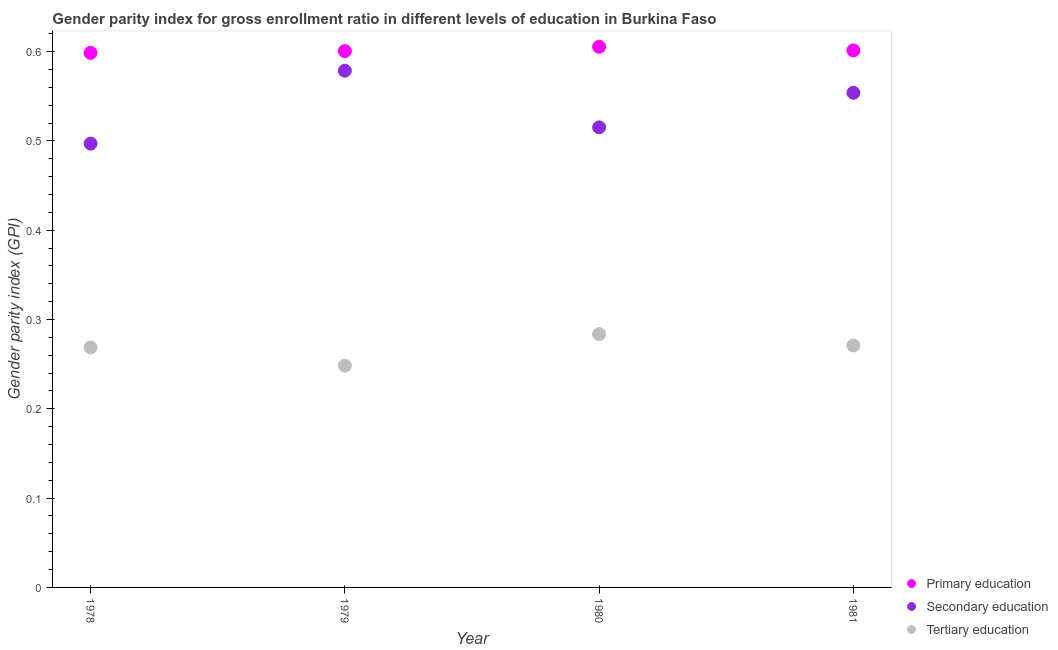Is the number of dotlines equal to the number of legend labels?
Provide a succinct answer. Yes. What is the gender parity index in secondary education in 1978?
Your answer should be compact. 0.5. Across all years, what is the maximum gender parity index in tertiary education?
Your response must be concise. 0.28. Across all years, what is the minimum gender parity index in secondary education?
Ensure brevity in your answer.  0.5. In which year was the gender parity index in primary education minimum?
Keep it short and to the point. 1978. What is the total gender parity index in secondary education in the graph?
Provide a succinct answer. 2.14. What is the difference between the gender parity index in primary education in 1978 and that in 1979?
Your answer should be compact. -0. What is the difference between the gender parity index in secondary education in 1979 and the gender parity index in primary education in 1978?
Your response must be concise. -0.02. What is the average gender parity index in secondary education per year?
Your response must be concise. 0.54. In the year 1978, what is the difference between the gender parity index in tertiary education and gender parity index in secondary education?
Provide a short and direct response. -0.23. What is the ratio of the gender parity index in primary education in 1980 to that in 1981?
Keep it short and to the point. 1.01. Is the gender parity index in tertiary education in 1978 less than that in 1981?
Offer a terse response. Yes. Is the difference between the gender parity index in tertiary education in 1978 and 1980 greater than the difference between the gender parity index in secondary education in 1978 and 1980?
Ensure brevity in your answer.  Yes. What is the difference between the highest and the second highest gender parity index in primary education?
Make the answer very short. 0. What is the difference between the highest and the lowest gender parity index in secondary education?
Give a very brief answer. 0.08. Is it the case that in every year, the sum of the gender parity index in primary education and gender parity index in secondary education is greater than the gender parity index in tertiary education?
Provide a short and direct response. Yes. Is the gender parity index in tertiary education strictly greater than the gender parity index in primary education over the years?
Give a very brief answer. No. How many dotlines are there?
Your response must be concise. 3. How many legend labels are there?
Your answer should be very brief. 3. How are the legend labels stacked?
Provide a succinct answer. Vertical. What is the title of the graph?
Offer a very short reply. Gender parity index for gross enrollment ratio in different levels of education in Burkina Faso. What is the label or title of the Y-axis?
Offer a terse response. Gender parity index (GPI). What is the Gender parity index (GPI) in Primary education in 1978?
Provide a succinct answer. 0.6. What is the Gender parity index (GPI) of Secondary education in 1978?
Offer a terse response. 0.5. What is the Gender parity index (GPI) of Tertiary education in 1978?
Ensure brevity in your answer.  0.27. What is the Gender parity index (GPI) of Primary education in 1979?
Ensure brevity in your answer.  0.6. What is the Gender parity index (GPI) of Secondary education in 1979?
Provide a succinct answer. 0.58. What is the Gender parity index (GPI) in Tertiary education in 1979?
Provide a succinct answer. 0.25. What is the Gender parity index (GPI) of Primary education in 1980?
Your response must be concise. 0.61. What is the Gender parity index (GPI) in Secondary education in 1980?
Give a very brief answer. 0.52. What is the Gender parity index (GPI) of Tertiary education in 1980?
Provide a succinct answer. 0.28. What is the Gender parity index (GPI) of Primary education in 1981?
Your response must be concise. 0.6. What is the Gender parity index (GPI) in Secondary education in 1981?
Your answer should be compact. 0.55. What is the Gender parity index (GPI) in Tertiary education in 1981?
Your answer should be very brief. 0.27. Across all years, what is the maximum Gender parity index (GPI) in Primary education?
Ensure brevity in your answer.  0.61. Across all years, what is the maximum Gender parity index (GPI) in Secondary education?
Ensure brevity in your answer.  0.58. Across all years, what is the maximum Gender parity index (GPI) of Tertiary education?
Offer a very short reply. 0.28. Across all years, what is the minimum Gender parity index (GPI) of Primary education?
Your response must be concise. 0.6. Across all years, what is the minimum Gender parity index (GPI) in Secondary education?
Your response must be concise. 0.5. Across all years, what is the minimum Gender parity index (GPI) of Tertiary education?
Provide a short and direct response. 0.25. What is the total Gender parity index (GPI) of Primary education in the graph?
Your answer should be very brief. 2.41. What is the total Gender parity index (GPI) in Secondary education in the graph?
Keep it short and to the point. 2.14. What is the total Gender parity index (GPI) of Tertiary education in the graph?
Offer a terse response. 1.07. What is the difference between the Gender parity index (GPI) in Primary education in 1978 and that in 1979?
Ensure brevity in your answer.  -0. What is the difference between the Gender parity index (GPI) in Secondary education in 1978 and that in 1979?
Keep it short and to the point. -0.08. What is the difference between the Gender parity index (GPI) in Tertiary education in 1978 and that in 1979?
Provide a succinct answer. 0.02. What is the difference between the Gender parity index (GPI) in Primary education in 1978 and that in 1980?
Your answer should be compact. -0.01. What is the difference between the Gender parity index (GPI) in Secondary education in 1978 and that in 1980?
Your answer should be very brief. -0.02. What is the difference between the Gender parity index (GPI) in Tertiary education in 1978 and that in 1980?
Offer a terse response. -0.01. What is the difference between the Gender parity index (GPI) in Primary education in 1978 and that in 1981?
Offer a terse response. -0. What is the difference between the Gender parity index (GPI) of Secondary education in 1978 and that in 1981?
Provide a succinct answer. -0.06. What is the difference between the Gender parity index (GPI) in Tertiary education in 1978 and that in 1981?
Your answer should be compact. -0. What is the difference between the Gender parity index (GPI) of Primary education in 1979 and that in 1980?
Offer a very short reply. -0. What is the difference between the Gender parity index (GPI) of Secondary education in 1979 and that in 1980?
Your answer should be very brief. 0.06. What is the difference between the Gender parity index (GPI) of Tertiary education in 1979 and that in 1980?
Your response must be concise. -0.04. What is the difference between the Gender parity index (GPI) in Primary education in 1979 and that in 1981?
Provide a short and direct response. -0. What is the difference between the Gender parity index (GPI) of Secondary education in 1979 and that in 1981?
Your response must be concise. 0.02. What is the difference between the Gender parity index (GPI) of Tertiary education in 1979 and that in 1981?
Offer a very short reply. -0.02. What is the difference between the Gender parity index (GPI) of Primary education in 1980 and that in 1981?
Make the answer very short. 0. What is the difference between the Gender parity index (GPI) in Secondary education in 1980 and that in 1981?
Your answer should be compact. -0.04. What is the difference between the Gender parity index (GPI) in Tertiary education in 1980 and that in 1981?
Give a very brief answer. 0.01. What is the difference between the Gender parity index (GPI) in Primary education in 1978 and the Gender parity index (GPI) in Tertiary education in 1979?
Your answer should be compact. 0.35. What is the difference between the Gender parity index (GPI) in Secondary education in 1978 and the Gender parity index (GPI) in Tertiary education in 1979?
Give a very brief answer. 0.25. What is the difference between the Gender parity index (GPI) of Primary education in 1978 and the Gender parity index (GPI) of Secondary education in 1980?
Your answer should be compact. 0.08. What is the difference between the Gender parity index (GPI) of Primary education in 1978 and the Gender parity index (GPI) of Tertiary education in 1980?
Offer a very short reply. 0.31. What is the difference between the Gender parity index (GPI) in Secondary education in 1978 and the Gender parity index (GPI) in Tertiary education in 1980?
Make the answer very short. 0.21. What is the difference between the Gender parity index (GPI) of Primary education in 1978 and the Gender parity index (GPI) of Secondary education in 1981?
Ensure brevity in your answer.  0.04. What is the difference between the Gender parity index (GPI) of Primary education in 1978 and the Gender parity index (GPI) of Tertiary education in 1981?
Provide a succinct answer. 0.33. What is the difference between the Gender parity index (GPI) of Secondary education in 1978 and the Gender parity index (GPI) of Tertiary education in 1981?
Your answer should be very brief. 0.23. What is the difference between the Gender parity index (GPI) of Primary education in 1979 and the Gender parity index (GPI) of Secondary education in 1980?
Make the answer very short. 0.09. What is the difference between the Gender parity index (GPI) of Primary education in 1979 and the Gender parity index (GPI) of Tertiary education in 1980?
Offer a very short reply. 0.32. What is the difference between the Gender parity index (GPI) of Secondary education in 1979 and the Gender parity index (GPI) of Tertiary education in 1980?
Offer a terse response. 0.29. What is the difference between the Gender parity index (GPI) of Primary education in 1979 and the Gender parity index (GPI) of Secondary education in 1981?
Provide a short and direct response. 0.05. What is the difference between the Gender parity index (GPI) in Primary education in 1979 and the Gender parity index (GPI) in Tertiary education in 1981?
Offer a terse response. 0.33. What is the difference between the Gender parity index (GPI) of Secondary education in 1979 and the Gender parity index (GPI) of Tertiary education in 1981?
Ensure brevity in your answer.  0.31. What is the difference between the Gender parity index (GPI) in Primary education in 1980 and the Gender parity index (GPI) in Secondary education in 1981?
Your response must be concise. 0.05. What is the difference between the Gender parity index (GPI) of Primary education in 1980 and the Gender parity index (GPI) of Tertiary education in 1981?
Your answer should be very brief. 0.33. What is the difference between the Gender parity index (GPI) of Secondary education in 1980 and the Gender parity index (GPI) of Tertiary education in 1981?
Give a very brief answer. 0.24. What is the average Gender parity index (GPI) of Primary education per year?
Your response must be concise. 0.6. What is the average Gender parity index (GPI) in Secondary education per year?
Your response must be concise. 0.54. What is the average Gender parity index (GPI) of Tertiary education per year?
Keep it short and to the point. 0.27. In the year 1978, what is the difference between the Gender parity index (GPI) of Primary education and Gender parity index (GPI) of Secondary education?
Make the answer very short. 0.1. In the year 1978, what is the difference between the Gender parity index (GPI) of Primary education and Gender parity index (GPI) of Tertiary education?
Give a very brief answer. 0.33. In the year 1978, what is the difference between the Gender parity index (GPI) in Secondary education and Gender parity index (GPI) in Tertiary education?
Provide a succinct answer. 0.23. In the year 1979, what is the difference between the Gender parity index (GPI) in Primary education and Gender parity index (GPI) in Secondary education?
Make the answer very short. 0.02. In the year 1979, what is the difference between the Gender parity index (GPI) in Primary education and Gender parity index (GPI) in Tertiary education?
Provide a succinct answer. 0.35. In the year 1979, what is the difference between the Gender parity index (GPI) of Secondary education and Gender parity index (GPI) of Tertiary education?
Offer a very short reply. 0.33. In the year 1980, what is the difference between the Gender parity index (GPI) of Primary education and Gender parity index (GPI) of Secondary education?
Give a very brief answer. 0.09. In the year 1980, what is the difference between the Gender parity index (GPI) of Primary education and Gender parity index (GPI) of Tertiary education?
Offer a terse response. 0.32. In the year 1980, what is the difference between the Gender parity index (GPI) of Secondary education and Gender parity index (GPI) of Tertiary education?
Your answer should be very brief. 0.23. In the year 1981, what is the difference between the Gender parity index (GPI) in Primary education and Gender parity index (GPI) in Secondary education?
Offer a very short reply. 0.05. In the year 1981, what is the difference between the Gender parity index (GPI) of Primary education and Gender parity index (GPI) of Tertiary education?
Ensure brevity in your answer.  0.33. In the year 1981, what is the difference between the Gender parity index (GPI) in Secondary education and Gender parity index (GPI) in Tertiary education?
Your answer should be compact. 0.28. What is the ratio of the Gender parity index (GPI) in Secondary education in 1978 to that in 1979?
Give a very brief answer. 0.86. What is the ratio of the Gender parity index (GPI) of Tertiary education in 1978 to that in 1979?
Provide a short and direct response. 1.08. What is the ratio of the Gender parity index (GPI) in Primary education in 1978 to that in 1980?
Keep it short and to the point. 0.99. What is the ratio of the Gender parity index (GPI) of Secondary education in 1978 to that in 1980?
Provide a succinct answer. 0.96. What is the ratio of the Gender parity index (GPI) in Primary education in 1978 to that in 1981?
Provide a succinct answer. 1. What is the ratio of the Gender parity index (GPI) of Secondary education in 1978 to that in 1981?
Ensure brevity in your answer.  0.9. What is the ratio of the Gender parity index (GPI) of Primary education in 1979 to that in 1980?
Your answer should be very brief. 0.99. What is the ratio of the Gender parity index (GPI) in Secondary education in 1979 to that in 1980?
Your answer should be very brief. 1.12. What is the ratio of the Gender parity index (GPI) of Tertiary education in 1979 to that in 1980?
Give a very brief answer. 0.88. What is the ratio of the Gender parity index (GPI) of Primary education in 1979 to that in 1981?
Provide a short and direct response. 1. What is the ratio of the Gender parity index (GPI) of Secondary education in 1979 to that in 1981?
Your answer should be compact. 1.04. What is the ratio of the Gender parity index (GPI) in Tertiary education in 1979 to that in 1981?
Ensure brevity in your answer.  0.92. What is the ratio of the Gender parity index (GPI) in Primary education in 1980 to that in 1981?
Provide a short and direct response. 1.01. What is the ratio of the Gender parity index (GPI) of Secondary education in 1980 to that in 1981?
Provide a succinct answer. 0.93. What is the ratio of the Gender parity index (GPI) in Tertiary education in 1980 to that in 1981?
Keep it short and to the point. 1.05. What is the difference between the highest and the second highest Gender parity index (GPI) of Primary education?
Make the answer very short. 0. What is the difference between the highest and the second highest Gender parity index (GPI) in Secondary education?
Your answer should be compact. 0.02. What is the difference between the highest and the second highest Gender parity index (GPI) in Tertiary education?
Offer a terse response. 0.01. What is the difference between the highest and the lowest Gender parity index (GPI) of Primary education?
Provide a succinct answer. 0.01. What is the difference between the highest and the lowest Gender parity index (GPI) of Secondary education?
Ensure brevity in your answer.  0.08. What is the difference between the highest and the lowest Gender parity index (GPI) of Tertiary education?
Make the answer very short. 0.04. 